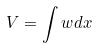<formula> <loc_0><loc_0><loc_500><loc_500>V = \int w d x</formula> 